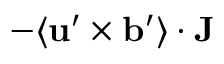<formula> <loc_0><loc_0><loc_500><loc_500>- \langle { { u } ^ { \prime } \times { b } ^ { \prime } } \rangle \cdot { J }</formula> 